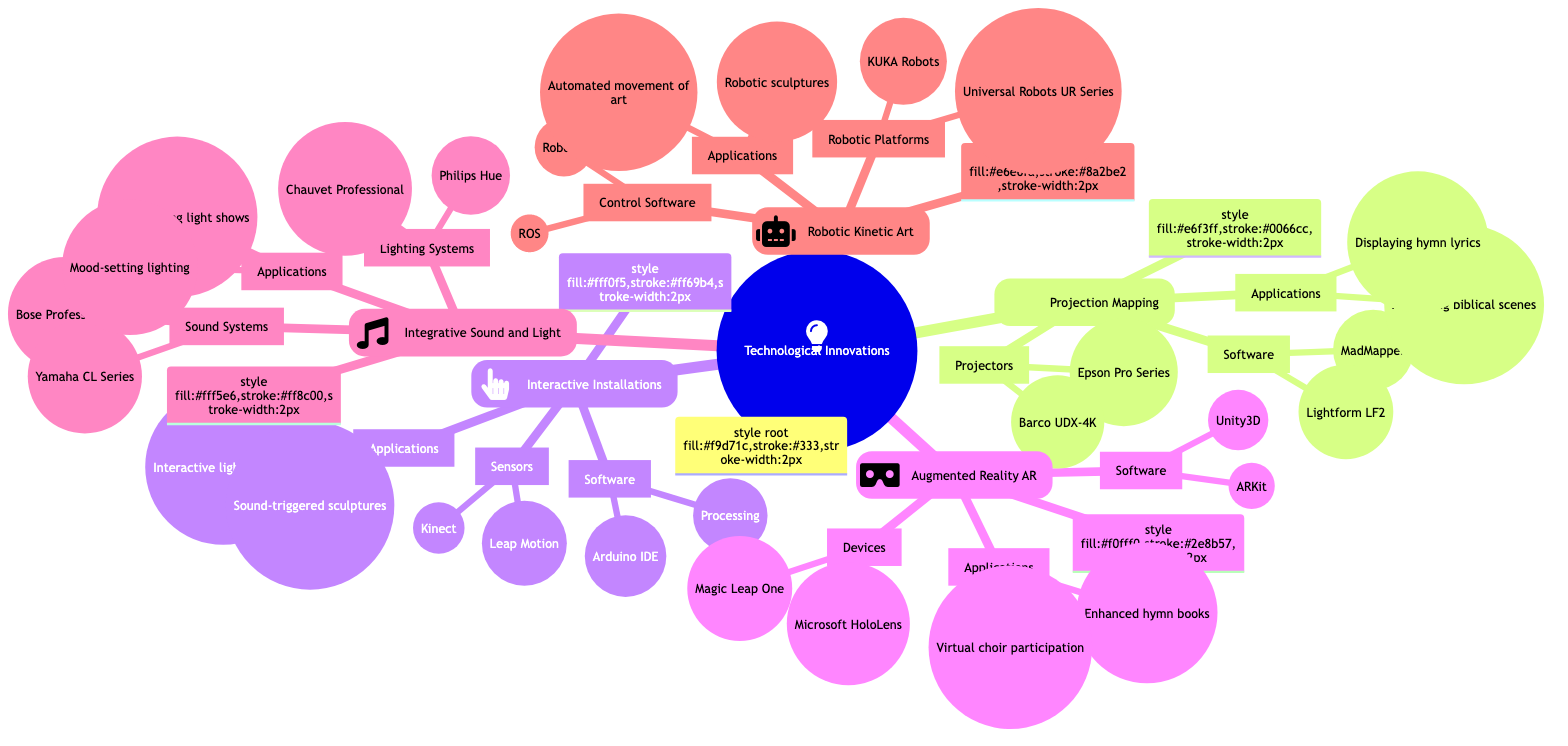What category does 'Projection Mapping' belong to? 'Projection Mapping' is listed directly under the main category 'Technological Innovations', indicating it is one of the key components of that broader topic.
Answer: Projection Mapping How many main categories are represented in the diagram? The diagram shows five main categories under 'Technological Innovations': Projection Mapping, Interactive Installations, Augmented Reality, Integrative Sound and Light, and Robotic Kinetic Art.
Answer: 5 What software is used for 'Augmented Reality'? Under 'Augmented Reality', the software listed includes Unity3D and ARKit. Both are essential for developing AR applications.
Answer: Unity3D, ARKit Which sensors are associated with 'Interactive Installations'? The sensors listed for 'Interactive Installations' are Kinect and Leap Motion, which are critical in enabling human interaction with these artistic installations.
Answer: Kinect, Leap Motion What is the application of 'Integrative Sound and Light Systems' that focuses on mood? One application is mood-setting lighting for different parts of a service, which enhances the worship experience by creating an appropriate ambiance.
Answer: Mood-setting lighting What type of robotic platforms are mentioned under 'Robotic Kinetic Art'? The diagram includes Universal Robots UR Series and KUKA Robots, which are examples of robotic platforms that can be incorporated into kinetic art.
Answer: Universal Robots UR Series, KUKA Robots Which application of 'Projection Mapping' involves hymn lyrics? The application that involves hymn lyrics is displaying hymn lyrics with visual effects, which enriches the worship experience through visual artistry.
Answer: Displaying hymn lyrics with visual effects How do 'Interactive Installations' enhance worship spaces? Interactive Installations create participative experiences through interactive light displays and sound-triggered kinetic sculptures, engaging the congregation in unique ways.
Answer: Interactive light displays, Sound-triggered sculptures Which devices are used in 'Augmented Reality'? The devices listed under 'Augmented Reality' are Microsoft HoloLens and Magic Leap One, which are used to experience augmented content.
Answer: Microsoft HoloLens, Magic Leap One 